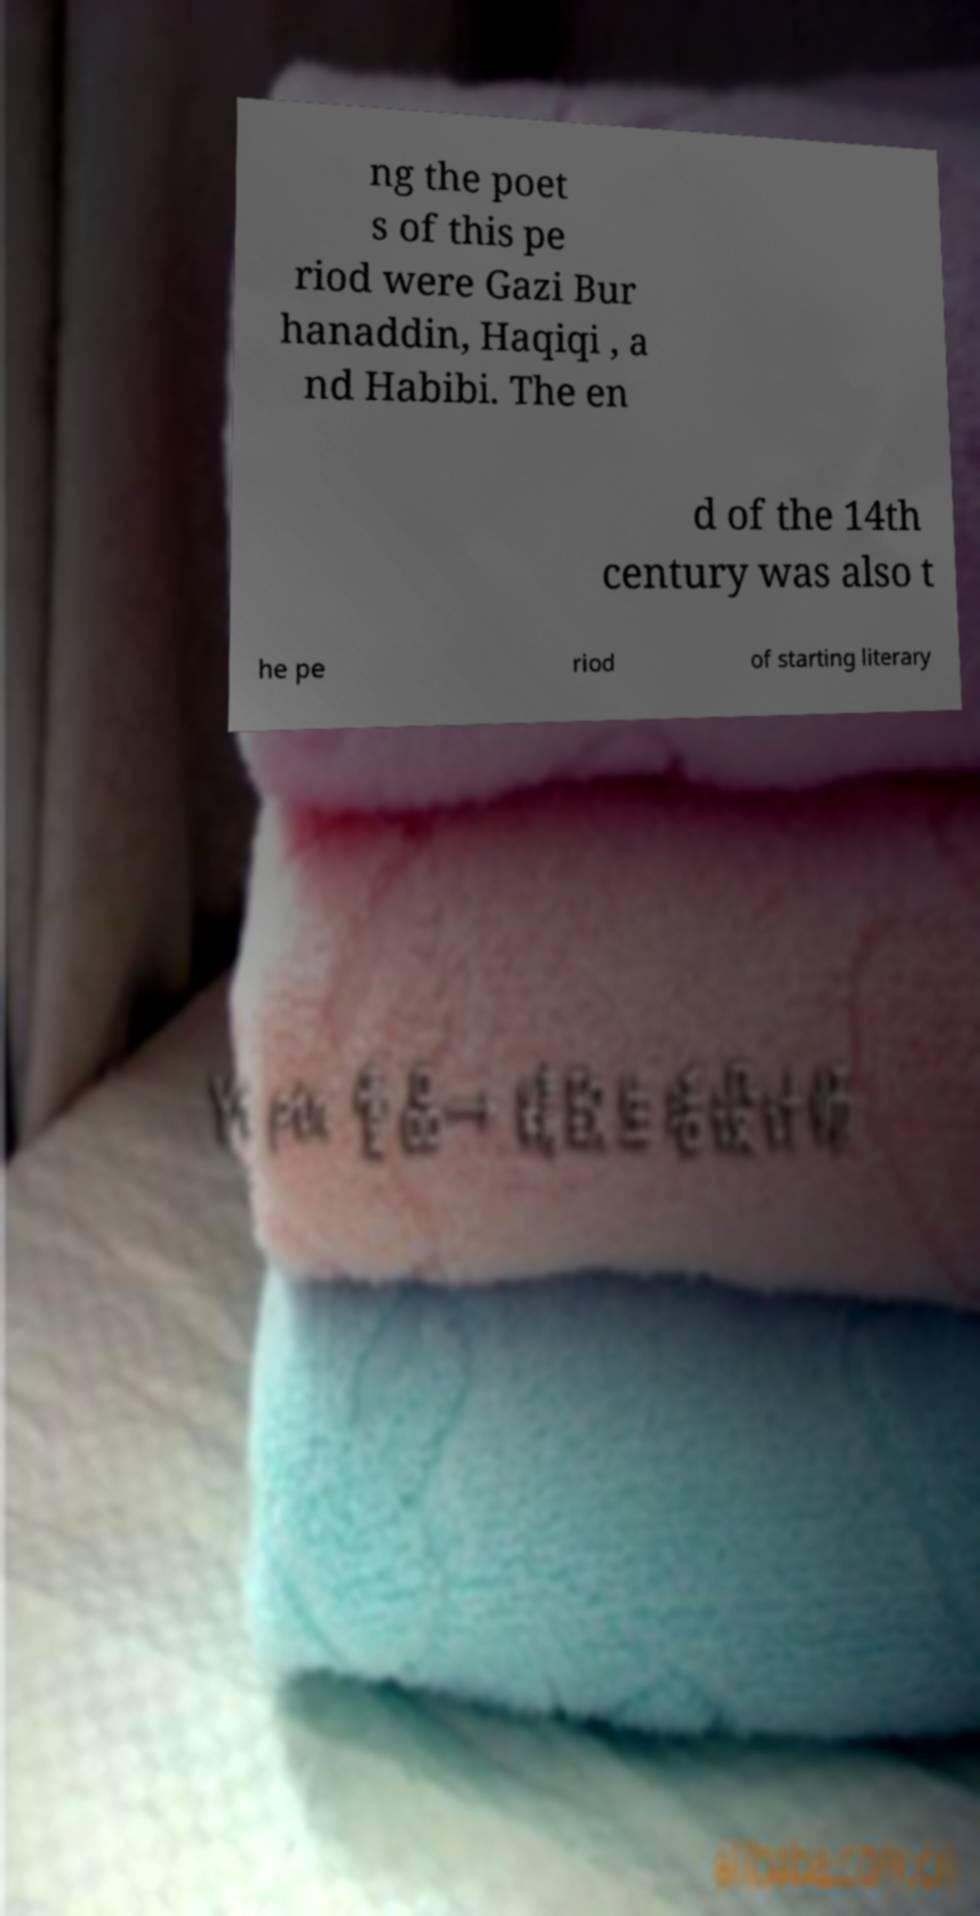I need the written content from this picture converted into text. Can you do that? ng the poet s of this pe riod were Gazi Bur hanaddin, Haqiqi , a nd Habibi. The en d of the 14th century was also t he pe riod of starting literary 